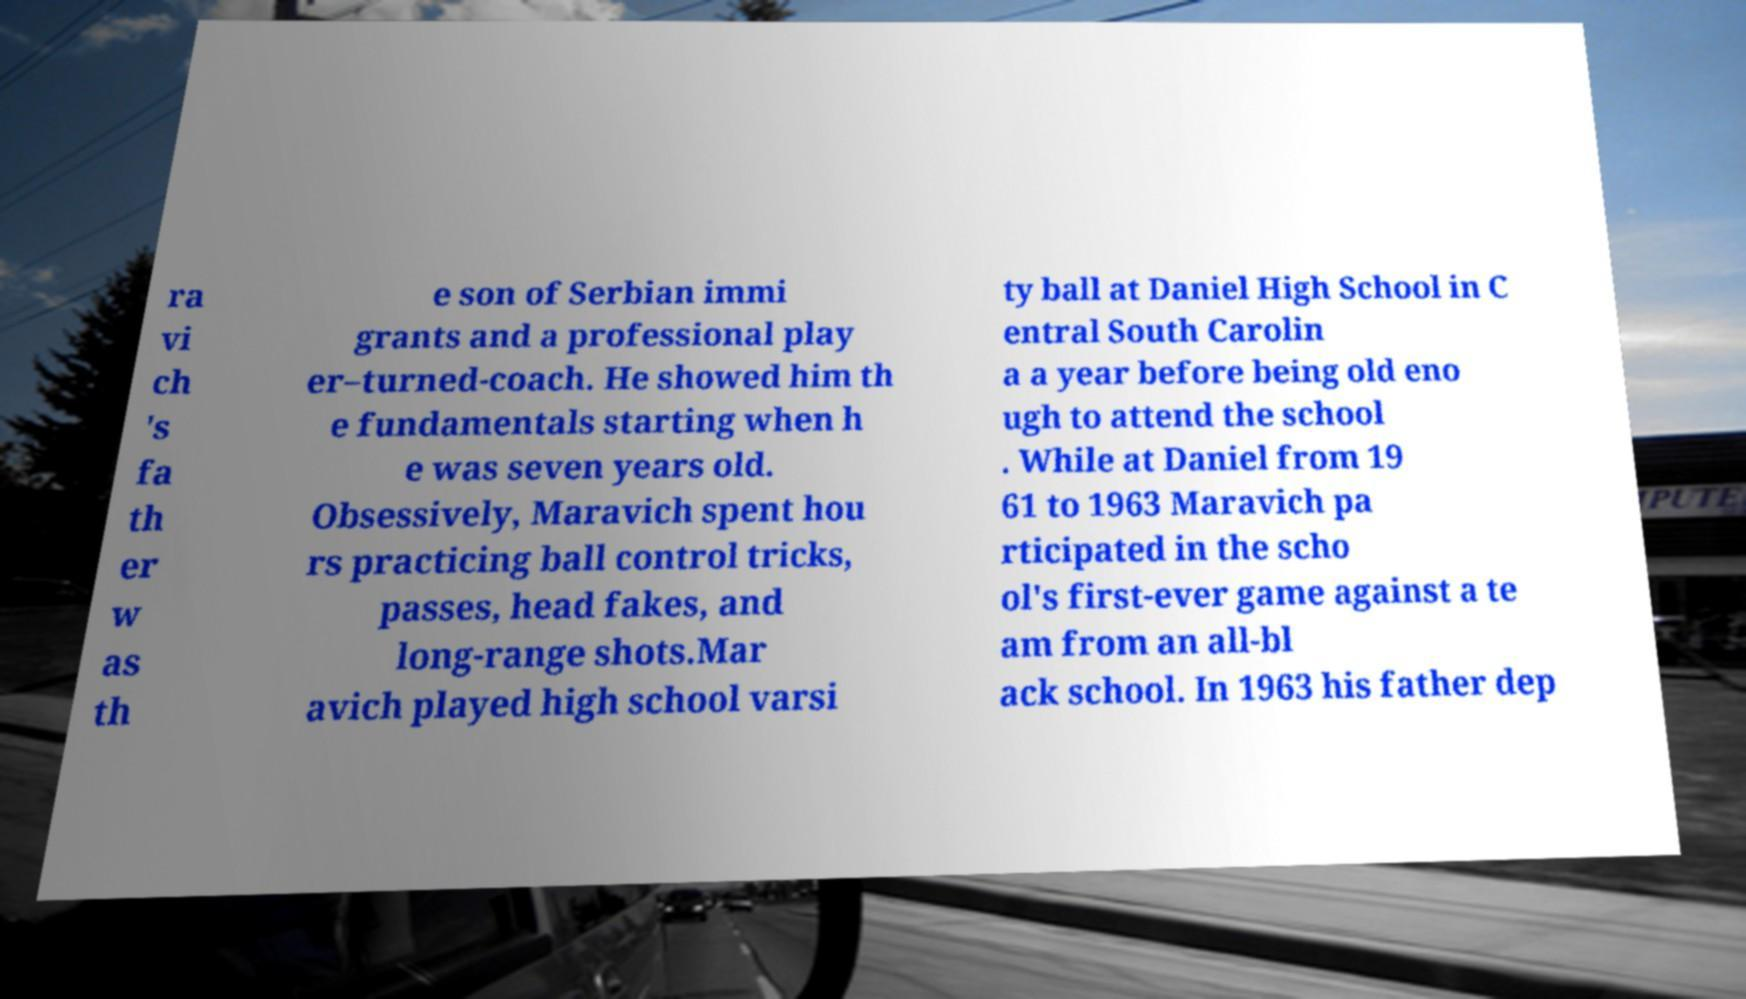Can you read and provide the text displayed in the image?This photo seems to have some interesting text. Can you extract and type it out for me? ra vi ch 's fa th er w as th e son of Serbian immi grants and a professional play er–turned-coach. He showed him th e fundamentals starting when h e was seven years old. Obsessively, Maravich spent hou rs practicing ball control tricks, passes, head fakes, and long-range shots.Mar avich played high school varsi ty ball at Daniel High School in C entral South Carolin a a year before being old eno ugh to attend the school . While at Daniel from 19 61 to 1963 Maravich pa rticipated in the scho ol's first-ever game against a te am from an all-bl ack school. In 1963 his father dep 